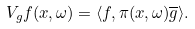Convert formula to latex. <formula><loc_0><loc_0><loc_500><loc_500>V _ { g } f ( x , \omega ) = \langle f , \pi ( x , \omega ) \overline { g } \rangle .</formula> 